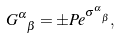Convert formula to latex. <formula><loc_0><loc_0><loc_500><loc_500>G ^ { \alpha } _ { \ \beta } = \pm P e ^ { \sigma ^ { \alpha } _ { \ \beta } } ,</formula> 